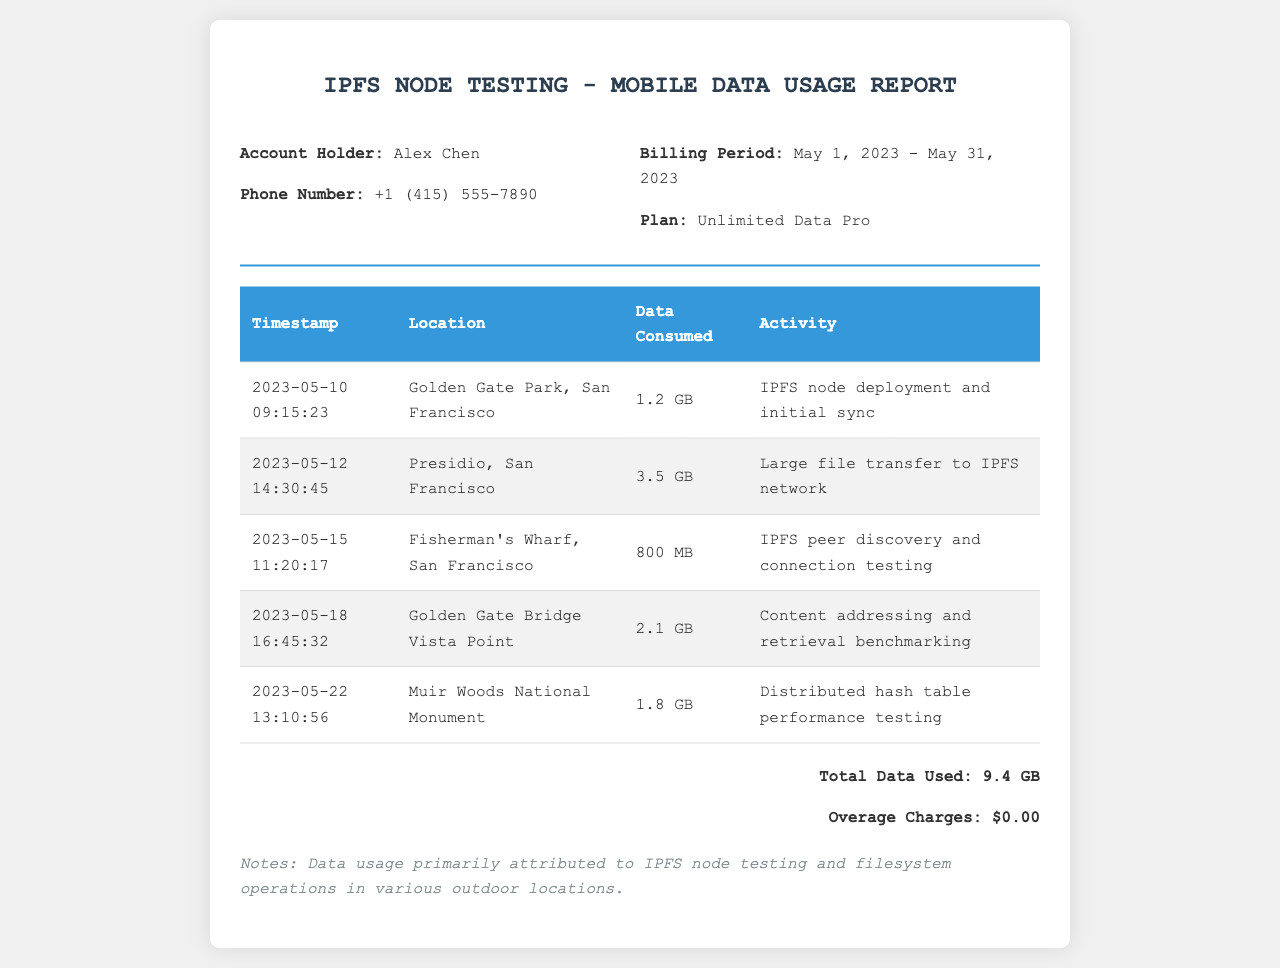what is the account holder's name? The document states the account holder's name as Alex Chen.
Answer: Alex Chen what is the phone number listed? The phone number provided in the document is +1 (415) 555-7890.
Answer: +1 (415) 555-7890 what is the total data used during the billing period? The total data usage calculated from the records is 9.4 GB.
Answer: 9.4 GB what activity was performed on May 12, 2023? On this date, a large file transfer to the IPFS network was performed.
Answer: Large file transfer to IPFS network how many gigabytes were consumed during the testing at Fisherman's Wharf? The document shows that 800 MB was consumed at Fisherman's Wharf. The equivalent in gigabytes is 0.8 GB.
Answer: 800 MB which location had the highest data consumption? The highest data consumption occurred at the Presidio, San Francisco with 3.5 GB used.
Answer: Presidio, San Francisco what is the billing period for the mobile data usage report? The billing period mentioned in the document is May 1, 2023 - May 31, 2023.
Answer: May 1, 2023 - May 31, 2023 what was the purpose of the testing at Muir Woods National Monument? The purpose of the testing there was distributed hash table performance testing.
Answer: Distributed hash table performance testing how much are the overage charges for the period? According to the document, there are no overage charges incurred during the billing period.
Answer: $0.00 